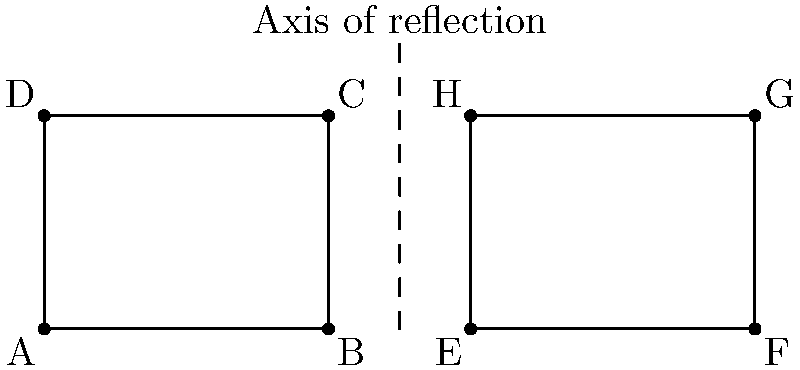A building facade design needs to be reflected across a vertical axis for symmetrical appearance. The original design is represented by rectangle ABCD, where A(0,0), B(4,0), C(4,3), and D(0,3). If the vertical axis of reflection is at x = 5, what are the coordinates of point G in the reflected design? To solve this problem, we need to follow these steps:

1) Identify the original point to be reflected:
   Point C(4,3) in the original design corresponds to point G in the reflected design.

2) Calculate the distance from point C to the axis of reflection:
   Distance = 5 - 4 = 1 unit

3) Apply the reflection:
   - The y-coordinate remains the same: 3
   - The x-coordinate will be as far to the right of the axis as C is to the left
   - So, the new x-coordinate = 5 + 1 = 6

4) Therefore, the coordinates of point G in the reflected design are (6,3)

5) To verify:
   - Original point C(4,3) is 1 unit left of the axis at x = 5
   - Reflected point G(6,3) is 1 unit right of the axis at x = 5
   - Both points have the same y-coordinate

This reflection creates the symmetrical appearance required for the building facade design.
Answer: G(6,3) 